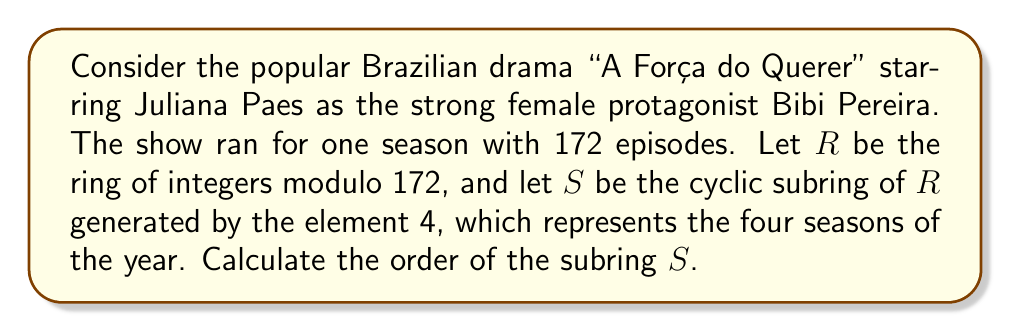Help me with this question. To solve this problem, we need to follow these steps:

1) First, we need to understand that $R = \mathbb{Z}_{172}$, the ring of integers modulo 172.

2) The subring $S$ is generated by the element 4. This means $S = \langle 4 \rangle = \{4k \mod 172 : k \in \mathbb{Z}\}$.

3) To find the order of $S$, we need to find the smallest positive integer $n$ such that $4n \equiv 0 \pmod{172}$.

4) This is equivalent to solving the equation:

   $4n = 172m$ for some integer $m$

5) Simplifying:

   $n = 43m$

6) The smallest positive $n$ that satisfies this is when $m = 1$, so $n = 43$.

7) Therefore, the elements of $S$ are:

   $\{0, 4, 8, 12, ..., 168\}$

8) We can confirm that there are indeed 43 elements in this set (0 and 42 non-zero elements).

9) The order of a subring is the number of elements it contains. Therefore, the order of $S$ is 43.
Answer: The order of the cyclic subring $S$ is 43. 